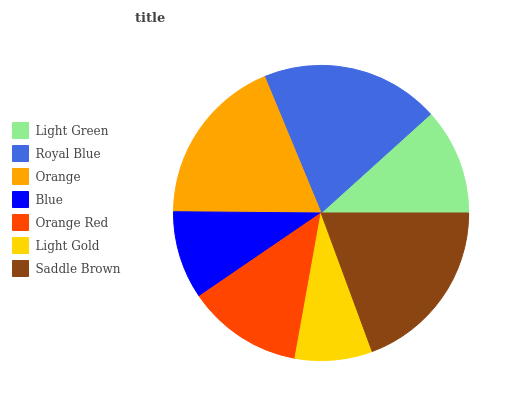Is Light Gold the minimum?
Answer yes or no. Yes. Is Royal Blue the maximum?
Answer yes or no. Yes. Is Orange the minimum?
Answer yes or no. No. Is Orange the maximum?
Answer yes or no. No. Is Royal Blue greater than Orange?
Answer yes or no. Yes. Is Orange less than Royal Blue?
Answer yes or no. Yes. Is Orange greater than Royal Blue?
Answer yes or no. No. Is Royal Blue less than Orange?
Answer yes or no. No. Is Orange Red the high median?
Answer yes or no. Yes. Is Orange Red the low median?
Answer yes or no. Yes. Is Light Green the high median?
Answer yes or no. No. Is Royal Blue the low median?
Answer yes or no. No. 